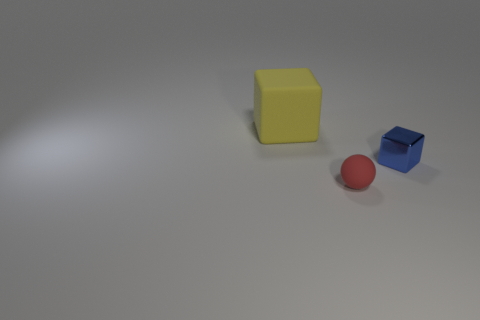Add 3 big yellow objects. How many objects exist? 6 Subtract all blue blocks. How many blocks are left? 1 Subtract all balls. How many objects are left? 2 Add 2 small cyan matte spheres. How many small cyan matte spheres exist? 2 Subtract 0 cyan blocks. How many objects are left? 3 Subtract all cyan balls. Subtract all brown blocks. How many balls are left? 1 Subtract all large blocks. Subtract all small red balls. How many objects are left? 1 Add 3 small red matte spheres. How many small red matte spheres are left? 4 